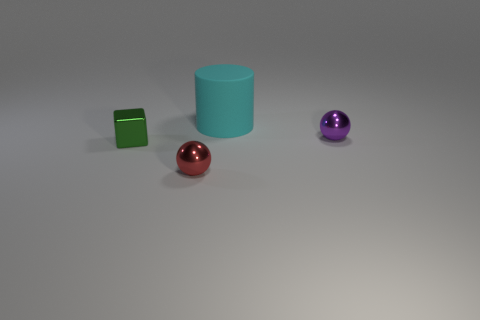Is the object left of the red sphere made of the same material as the sphere that is on the left side of the big cylinder?
Make the answer very short. Yes. Is there any other thing that has the same shape as the purple metallic object?
Your response must be concise. Yes. Are the tiny green cube and the tiny sphere to the right of the tiny red ball made of the same material?
Provide a succinct answer. Yes. What color is the small object on the right side of the cyan matte object that is behind the tiny shiny thing in front of the green thing?
Your answer should be very brief. Purple. There is a red thing that is the same size as the cube; what shape is it?
Provide a succinct answer. Sphere. Is there anything else that is the same size as the cyan cylinder?
Give a very brief answer. No. There is a object that is behind the purple shiny sphere; does it have the same size as the thing that is on the right side of the cyan cylinder?
Make the answer very short. No. How big is the ball to the right of the red shiny thing?
Your answer should be compact. Small. The metal cube that is the same size as the red object is what color?
Your response must be concise. Green. Is the size of the rubber object the same as the red metal thing?
Give a very brief answer. No. 